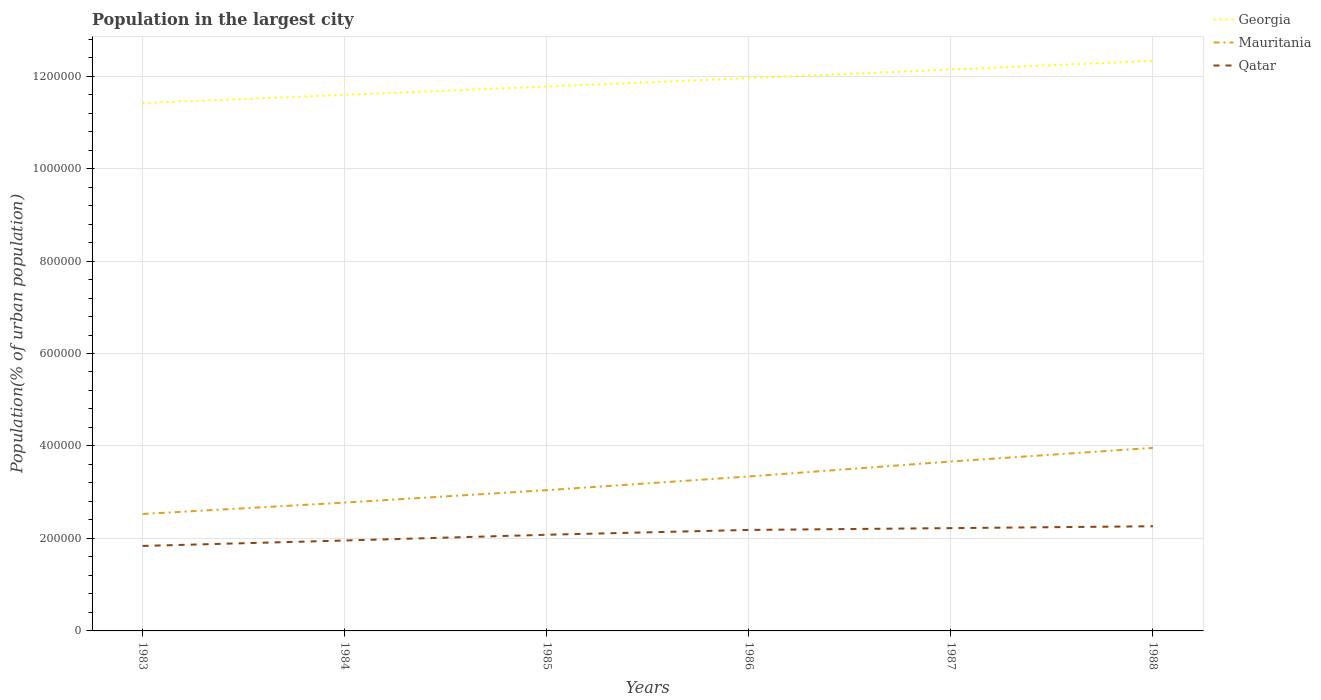Across all years, what is the maximum population in the largest city in Mauritania?
Provide a succinct answer. 2.53e+05. In which year was the population in the largest city in Qatar maximum?
Your answer should be very brief. 1983. What is the total population in the largest city in Georgia in the graph?
Make the answer very short. -1.85e+04. What is the difference between the highest and the second highest population in the largest city in Mauritania?
Ensure brevity in your answer.  1.43e+05. Are the values on the major ticks of Y-axis written in scientific E-notation?
Your answer should be very brief. No. Does the graph contain any zero values?
Provide a short and direct response. No. Does the graph contain grids?
Offer a very short reply. Yes. How are the legend labels stacked?
Make the answer very short. Vertical. What is the title of the graph?
Keep it short and to the point. Population in the largest city. What is the label or title of the Y-axis?
Provide a short and direct response. Population(% of urban population). What is the Population(% of urban population) in Georgia in 1983?
Provide a succinct answer. 1.14e+06. What is the Population(% of urban population) of Mauritania in 1983?
Give a very brief answer. 2.53e+05. What is the Population(% of urban population) of Qatar in 1983?
Your answer should be very brief. 1.84e+05. What is the Population(% of urban population) in Georgia in 1984?
Provide a succinct answer. 1.16e+06. What is the Population(% of urban population) of Mauritania in 1984?
Give a very brief answer. 2.78e+05. What is the Population(% of urban population) in Qatar in 1984?
Ensure brevity in your answer.  1.96e+05. What is the Population(% of urban population) in Georgia in 1985?
Provide a short and direct response. 1.18e+06. What is the Population(% of urban population) in Mauritania in 1985?
Your response must be concise. 3.04e+05. What is the Population(% of urban population) in Qatar in 1985?
Give a very brief answer. 2.08e+05. What is the Population(% of urban population) of Georgia in 1986?
Keep it short and to the point. 1.20e+06. What is the Population(% of urban population) of Mauritania in 1986?
Make the answer very short. 3.34e+05. What is the Population(% of urban population) of Qatar in 1986?
Ensure brevity in your answer.  2.18e+05. What is the Population(% of urban population) in Georgia in 1987?
Offer a very short reply. 1.21e+06. What is the Population(% of urban population) in Mauritania in 1987?
Your answer should be very brief. 3.66e+05. What is the Population(% of urban population) of Qatar in 1987?
Offer a terse response. 2.22e+05. What is the Population(% of urban population) in Georgia in 1988?
Offer a terse response. 1.23e+06. What is the Population(% of urban population) of Mauritania in 1988?
Provide a succinct answer. 3.96e+05. What is the Population(% of urban population) of Qatar in 1988?
Your answer should be very brief. 2.26e+05. Across all years, what is the maximum Population(% of urban population) of Georgia?
Provide a succinct answer. 1.23e+06. Across all years, what is the maximum Population(% of urban population) in Mauritania?
Make the answer very short. 3.96e+05. Across all years, what is the maximum Population(% of urban population) of Qatar?
Keep it short and to the point. 2.26e+05. Across all years, what is the minimum Population(% of urban population) in Georgia?
Offer a terse response. 1.14e+06. Across all years, what is the minimum Population(% of urban population) in Mauritania?
Your response must be concise. 2.53e+05. Across all years, what is the minimum Population(% of urban population) of Qatar?
Keep it short and to the point. 1.84e+05. What is the total Population(% of urban population) in Georgia in the graph?
Provide a short and direct response. 7.12e+06. What is the total Population(% of urban population) of Mauritania in the graph?
Offer a very short reply. 1.93e+06. What is the total Population(% of urban population) in Qatar in the graph?
Give a very brief answer. 1.25e+06. What is the difference between the Population(% of urban population) in Georgia in 1983 and that in 1984?
Your answer should be very brief. -1.77e+04. What is the difference between the Population(% of urban population) in Mauritania in 1983 and that in 1984?
Provide a short and direct response. -2.46e+04. What is the difference between the Population(% of urban population) in Qatar in 1983 and that in 1984?
Offer a very short reply. -1.17e+04. What is the difference between the Population(% of urban population) of Georgia in 1983 and that in 1985?
Your answer should be compact. -3.57e+04. What is the difference between the Population(% of urban population) in Mauritania in 1983 and that in 1985?
Your answer should be very brief. -5.15e+04. What is the difference between the Population(% of urban population) of Qatar in 1983 and that in 1985?
Provide a succinct answer. -2.42e+04. What is the difference between the Population(% of urban population) of Georgia in 1983 and that in 1986?
Provide a succinct answer. -5.39e+04. What is the difference between the Population(% of urban population) of Mauritania in 1983 and that in 1986?
Your response must be concise. -8.11e+04. What is the difference between the Population(% of urban population) of Qatar in 1983 and that in 1986?
Offer a very short reply. -3.46e+04. What is the difference between the Population(% of urban population) of Georgia in 1983 and that in 1987?
Make the answer very short. -7.25e+04. What is the difference between the Population(% of urban population) of Mauritania in 1983 and that in 1987?
Provide a succinct answer. -1.14e+05. What is the difference between the Population(% of urban population) in Qatar in 1983 and that in 1987?
Provide a short and direct response. -3.85e+04. What is the difference between the Population(% of urban population) in Georgia in 1983 and that in 1988?
Provide a succinct answer. -9.13e+04. What is the difference between the Population(% of urban population) in Mauritania in 1983 and that in 1988?
Your response must be concise. -1.43e+05. What is the difference between the Population(% of urban population) in Qatar in 1983 and that in 1988?
Your answer should be compact. -4.25e+04. What is the difference between the Population(% of urban population) of Georgia in 1984 and that in 1985?
Offer a terse response. -1.80e+04. What is the difference between the Population(% of urban population) of Mauritania in 1984 and that in 1985?
Ensure brevity in your answer.  -2.69e+04. What is the difference between the Population(% of urban population) of Qatar in 1984 and that in 1985?
Provide a succinct answer. -1.25e+04. What is the difference between the Population(% of urban population) in Georgia in 1984 and that in 1986?
Your response must be concise. -3.62e+04. What is the difference between the Population(% of urban population) in Mauritania in 1984 and that in 1986?
Offer a terse response. -5.65e+04. What is the difference between the Population(% of urban population) of Qatar in 1984 and that in 1986?
Make the answer very short. -2.29e+04. What is the difference between the Population(% of urban population) in Georgia in 1984 and that in 1987?
Provide a short and direct response. -5.47e+04. What is the difference between the Population(% of urban population) of Mauritania in 1984 and that in 1987?
Your answer should be very brief. -8.89e+04. What is the difference between the Population(% of urban population) in Qatar in 1984 and that in 1987?
Keep it short and to the point. -2.68e+04. What is the difference between the Population(% of urban population) in Georgia in 1984 and that in 1988?
Give a very brief answer. -7.36e+04. What is the difference between the Population(% of urban population) in Mauritania in 1984 and that in 1988?
Keep it short and to the point. -1.18e+05. What is the difference between the Population(% of urban population) in Qatar in 1984 and that in 1988?
Offer a terse response. -3.08e+04. What is the difference between the Population(% of urban population) in Georgia in 1985 and that in 1986?
Make the answer very short. -1.83e+04. What is the difference between the Population(% of urban population) in Mauritania in 1985 and that in 1986?
Offer a terse response. -2.96e+04. What is the difference between the Population(% of urban population) of Qatar in 1985 and that in 1986?
Your response must be concise. -1.04e+04. What is the difference between the Population(% of urban population) of Georgia in 1985 and that in 1987?
Your answer should be very brief. -3.68e+04. What is the difference between the Population(% of urban population) of Mauritania in 1985 and that in 1987?
Your answer should be very brief. -6.20e+04. What is the difference between the Population(% of urban population) of Qatar in 1985 and that in 1987?
Provide a short and direct response. -1.43e+04. What is the difference between the Population(% of urban population) of Georgia in 1985 and that in 1988?
Make the answer very short. -5.56e+04. What is the difference between the Population(% of urban population) of Mauritania in 1985 and that in 1988?
Offer a very short reply. -9.15e+04. What is the difference between the Population(% of urban population) in Qatar in 1985 and that in 1988?
Keep it short and to the point. -1.83e+04. What is the difference between the Population(% of urban population) in Georgia in 1986 and that in 1987?
Give a very brief answer. -1.85e+04. What is the difference between the Population(% of urban population) of Mauritania in 1986 and that in 1987?
Your answer should be very brief. -3.24e+04. What is the difference between the Population(% of urban population) of Qatar in 1986 and that in 1987?
Your answer should be compact. -3916. What is the difference between the Population(% of urban population) in Georgia in 1986 and that in 1988?
Your answer should be very brief. -3.74e+04. What is the difference between the Population(% of urban population) of Mauritania in 1986 and that in 1988?
Keep it short and to the point. -6.19e+04. What is the difference between the Population(% of urban population) in Qatar in 1986 and that in 1988?
Your answer should be very brief. -7908. What is the difference between the Population(% of urban population) in Georgia in 1987 and that in 1988?
Give a very brief answer. -1.89e+04. What is the difference between the Population(% of urban population) in Mauritania in 1987 and that in 1988?
Keep it short and to the point. -2.95e+04. What is the difference between the Population(% of urban population) of Qatar in 1987 and that in 1988?
Make the answer very short. -3992. What is the difference between the Population(% of urban population) of Georgia in 1983 and the Population(% of urban population) of Mauritania in 1984?
Your answer should be very brief. 8.64e+05. What is the difference between the Population(% of urban population) of Georgia in 1983 and the Population(% of urban population) of Qatar in 1984?
Provide a short and direct response. 9.46e+05. What is the difference between the Population(% of urban population) in Mauritania in 1983 and the Population(% of urban population) in Qatar in 1984?
Make the answer very short. 5.74e+04. What is the difference between the Population(% of urban population) in Georgia in 1983 and the Population(% of urban population) in Mauritania in 1985?
Provide a succinct answer. 8.37e+05. What is the difference between the Population(% of urban population) in Georgia in 1983 and the Population(% of urban population) in Qatar in 1985?
Give a very brief answer. 9.34e+05. What is the difference between the Population(% of urban population) in Mauritania in 1983 and the Population(% of urban population) in Qatar in 1985?
Provide a succinct answer. 4.49e+04. What is the difference between the Population(% of urban population) of Georgia in 1983 and the Population(% of urban population) of Mauritania in 1986?
Offer a terse response. 8.08e+05. What is the difference between the Population(% of urban population) of Georgia in 1983 and the Population(% of urban population) of Qatar in 1986?
Provide a short and direct response. 9.23e+05. What is the difference between the Population(% of urban population) of Mauritania in 1983 and the Population(% of urban population) of Qatar in 1986?
Provide a succinct answer. 3.45e+04. What is the difference between the Population(% of urban population) in Georgia in 1983 and the Population(% of urban population) in Mauritania in 1987?
Provide a succinct answer. 7.75e+05. What is the difference between the Population(% of urban population) in Georgia in 1983 and the Population(% of urban population) in Qatar in 1987?
Provide a succinct answer. 9.19e+05. What is the difference between the Population(% of urban population) in Mauritania in 1983 and the Population(% of urban population) in Qatar in 1987?
Offer a terse response. 3.06e+04. What is the difference between the Population(% of urban population) of Georgia in 1983 and the Population(% of urban population) of Mauritania in 1988?
Ensure brevity in your answer.  7.46e+05. What is the difference between the Population(% of urban population) in Georgia in 1983 and the Population(% of urban population) in Qatar in 1988?
Keep it short and to the point. 9.15e+05. What is the difference between the Population(% of urban population) in Mauritania in 1983 and the Population(% of urban population) in Qatar in 1988?
Provide a short and direct response. 2.66e+04. What is the difference between the Population(% of urban population) of Georgia in 1984 and the Population(% of urban population) of Mauritania in 1985?
Offer a very short reply. 8.55e+05. What is the difference between the Population(% of urban population) of Georgia in 1984 and the Population(% of urban population) of Qatar in 1985?
Give a very brief answer. 9.51e+05. What is the difference between the Population(% of urban population) in Mauritania in 1984 and the Population(% of urban population) in Qatar in 1985?
Ensure brevity in your answer.  6.95e+04. What is the difference between the Population(% of urban population) of Georgia in 1984 and the Population(% of urban population) of Mauritania in 1986?
Offer a terse response. 8.25e+05. What is the difference between the Population(% of urban population) in Georgia in 1984 and the Population(% of urban population) in Qatar in 1986?
Provide a short and direct response. 9.41e+05. What is the difference between the Population(% of urban population) in Mauritania in 1984 and the Population(% of urban population) in Qatar in 1986?
Your response must be concise. 5.91e+04. What is the difference between the Population(% of urban population) in Georgia in 1984 and the Population(% of urban population) in Mauritania in 1987?
Ensure brevity in your answer.  7.93e+05. What is the difference between the Population(% of urban population) in Georgia in 1984 and the Population(% of urban population) in Qatar in 1987?
Make the answer very short. 9.37e+05. What is the difference between the Population(% of urban population) in Mauritania in 1984 and the Population(% of urban population) in Qatar in 1987?
Provide a succinct answer. 5.52e+04. What is the difference between the Population(% of urban population) of Georgia in 1984 and the Population(% of urban population) of Mauritania in 1988?
Ensure brevity in your answer.  7.63e+05. What is the difference between the Population(% of urban population) of Georgia in 1984 and the Population(% of urban population) of Qatar in 1988?
Your answer should be compact. 9.33e+05. What is the difference between the Population(% of urban population) of Mauritania in 1984 and the Population(% of urban population) of Qatar in 1988?
Keep it short and to the point. 5.12e+04. What is the difference between the Population(% of urban population) in Georgia in 1985 and the Population(% of urban population) in Mauritania in 1986?
Make the answer very short. 8.43e+05. What is the difference between the Population(% of urban population) of Georgia in 1985 and the Population(% of urban population) of Qatar in 1986?
Your answer should be very brief. 9.59e+05. What is the difference between the Population(% of urban population) in Mauritania in 1985 and the Population(% of urban population) in Qatar in 1986?
Ensure brevity in your answer.  8.60e+04. What is the difference between the Population(% of urban population) of Georgia in 1985 and the Population(% of urban population) of Mauritania in 1987?
Offer a terse response. 8.11e+05. What is the difference between the Population(% of urban population) in Georgia in 1985 and the Population(% of urban population) in Qatar in 1987?
Provide a short and direct response. 9.55e+05. What is the difference between the Population(% of urban population) of Mauritania in 1985 and the Population(% of urban population) of Qatar in 1987?
Offer a very short reply. 8.21e+04. What is the difference between the Population(% of urban population) of Georgia in 1985 and the Population(% of urban population) of Mauritania in 1988?
Offer a terse response. 7.81e+05. What is the difference between the Population(% of urban population) in Georgia in 1985 and the Population(% of urban population) in Qatar in 1988?
Offer a terse response. 9.51e+05. What is the difference between the Population(% of urban population) of Mauritania in 1985 and the Population(% of urban population) of Qatar in 1988?
Make the answer very short. 7.81e+04. What is the difference between the Population(% of urban population) in Georgia in 1986 and the Population(% of urban population) in Mauritania in 1987?
Offer a terse response. 8.29e+05. What is the difference between the Population(% of urban population) in Georgia in 1986 and the Population(% of urban population) in Qatar in 1987?
Provide a succinct answer. 9.73e+05. What is the difference between the Population(% of urban population) in Mauritania in 1986 and the Population(% of urban population) in Qatar in 1987?
Keep it short and to the point. 1.12e+05. What is the difference between the Population(% of urban population) of Georgia in 1986 and the Population(% of urban population) of Mauritania in 1988?
Offer a terse response. 8.00e+05. What is the difference between the Population(% of urban population) of Georgia in 1986 and the Population(% of urban population) of Qatar in 1988?
Ensure brevity in your answer.  9.69e+05. What is the difference between the Population(% of urban population) of Mauritania in 1986 and the Population(% of urban population) of Qatar in 1988?
Your answer should be very brief. 1.08e+05. What is the difference between the Population(% of urban population) of Georgia in 1987 and the Population(% of urban population) of Mauritania in 1988?
Give a very brief answer. 8.18e+05. What is the difference between the Population(% of urban population) in Georgia in 1987 and the Population(% of urban population) in Qatar in 1988?
Provide a succinct answer. 9.88e+05. What is the difference between the Population(% of urban population) of Mauritania in 1987 and the Population(% of urban population) of Qatar in 1988?
Keep it short and to the point. 1.40e+05. What is the average Population(% of urban population) of Georgia per year?
Ensure brevity in your answer.  1.19e+06. What is the average Population(% of urban population) of Mauritania per year?
Make the answer very short. 3.22e+05. What is the average Population(% of urban population) of Qatar per year?
Your response must be concise. 2.09e+05. In the year 1983, what is the difference between the Population(% of urban population) of Georgia and Population(% of urban population) of Mauritania?
Provide a short and direct response. 8.89e+05. In the year 1983, what is the difference between the Population(% of urban population) of Georgia and Population(% of urban population) of Qatar?
Keep it short and to the point. 9.58e+05. In the year 1983, what is the difference between the Population(% of urban population) of Mauritania and Population(% of urban population) of Qatar?
Provide a short and direct response. 6.91e+04. In the year 1984, what is the difference between the Population(% of urban population) in Georgia and Population(% of urban population) in Mauritania?
Make the answer very short. 8.82e+05. In the year 1984, what is the difference between the Population(% of urban population) of Georgia and Population(% of urban population) of Qatar?
Offer a terse response. 9.64e+05. In the year 1984, what is the difference between the Population(% of urban population) in Mauritania and Population(% of urban population) in Qatar?
Make the answer very short. 8.20e+04. In the year 1985, what is the difference between the Population(% of urban population) in Georgia and Population(% of urban population) in Mauritania?
Your answer should be very brief. 8.73e+05. In the year 1985, what is the difference between the Population(% of urban population) in Georgia and Population(% of urban population) in Qatar?
Offer a terse response. 9.69e+05. In the year 1985, what is the difference between the Population(% of urban population) in Mauritania and Population(% of urban population) in Qatar?
Your answer should be very brief. 9.64e+04. In the year 1986, what is the difference between the Population(% of urban population) in Georgia and Population(% of urban population) in Mauritania?
Offer a terse response. 8.62e+05. In the year 1986, what is the difference between the Population(% of urban population) of Georgia and Population(% of urban population) of Qatar?
Your response must be concise. 9.77e+05. In the year 1986, what is the difference between the Population(% of urban population) of Mauritania and Population(% of urban population) of Qatar?
Offer a terse response. 1.16e+05. In the year 1987, what is the difference between the Population(% of urban population) in Georgia and Population(% of urban population) in Mauritania?
Give a very brief answer. 8.48e+05. In the year 1987, what is the difference between the Population(% of urban population) of Georgia and Population(% of urban population) of Qatar?
Provide a succinct answer. 9.92e+05. In the year 1987, what is the difference between the Population(% of urban population) in Mauritania and Population(% of urban population) in Qatar?
Make the answer very short. 1.44e+05. In the year 1988, what is the difference between the Population(% of urban population) of Georgia and Population(% of urban population) of Mauritania?
Give a very brief answer. 8.37e+05. In the year 1988, what is the difference between the Population(% of urban population) of Georgia and Population(% of urban population) of Qatar?
Make the answer very short. 1.01e+06. In the year 1988, what is the difference between the Population(% of urban population) in Mauritania and Population(% of urban population) in Qatar?
Give a very brief answer. 1.70e+05. What is the ratio of the Population(% of urban population) of Georgia in 1983 to that in 1984?
Give a very brief answer. 0.98. What is the ratio of the Population(% of urban population) of Mauritania in 1983 to that in 1984?
Offer a very short reply. 0.91. What is the ratio of the Population(% of urban population) in Qatar in 1983 to that in 1984?
Your response must be concise. 0.94. What is the ratio of the Population(% of urban population) in Georgia in 1983 to that in 1985?
Make the answer very short. 0.97. What is the ratio of the Population(% of urban population) of Mauritania in 1983 to that in 1985?
Give a very brief answer. 0.83. What is the ratio of the Population(% of urban population) of Qatar in 1983 to that in 1985?
Your answer should be very brief. 0.88. What is the ratio of the Population(% of urban population) in Georgia in 1983 to that in 1986?
Ensure brevity in your answer.  0.95. What is the ratio of the Population(% of urban population) of Mauritania in 1983 to that in 1986?
Ensure brevity in your answer.  0.76. What is the ratio of the Population(% of urban population) in Qatar in 1983 to that in 1986?
Make the answer very short. 0.84. What is the ratio of the Population(% of urban population) of Georgia in 1983 to that in 1987?
Your answer should be compact. 0.94. What is the ratio of the Population(% of urban population) of Mauritania in 1983 to that in 1987?
Your answer should be compact. 0.69. What is the ratio of the Population(% of urban population) in Qatar in 1983 to that in 1987?
Provide a succinct answer. 0.83. What is the ratio of the Population(% of urban population) in Georgia in 1983 to that in 1988?
Your response must be concise. 0.93. What is the ratio of the Population(% of urban population) in Mauritania in 1983 to that in 1988?
Keep it short and to the point. 0.64. What is the ratio of the Population(% of urban population) in Qatar in 1983 to that in 1988?
Keep it short and to the point. 0.81. What is the ratio of the Population(% of urban population) in Mauritania in 1984 to that in 1985?
Your answer should be compact. 0.91. What is the ratio of the Population(% of urban population) in Qatar in 1984 to that in 1985?
Ensure brevity in your answer.  0.94. What is the ratio of the Population(% of urban population) of Georgia in 1984 to that in 1986?
Offer a terse response. 0.97. What is the ratio of the Population(% of urban population) of Mauritania in 1984 to that in 1986?
Your answer should be very brief. 0.83. What is the ratio of the Population(% of urban population) in Qatar in 1984 to that in 1986?
Offer a terse response. 0.9. What is the ratio of the Population(% of urban population) of Georgia in 1984 to that in 1987?
Offer a terse response. 0.95. What is the ratio of the Population(% of urban population) in Mauritania in 1984 to that in 1987?
Offer a terse response. 0.76. What is the ratio of the Population(% of urban population) in Qatar in 1984 to that in 1987?
Your answer should be compact. 0.88. What is the ratio of the Population(% of urban population) of Georgia in 1984 to that in 1988?
Give a very brief answer. 0.94. What is the ratio of the Population(% of urban population) in Mauritania in 1984 to that in 1988?
Keep it short and to the point. 0.7. What is the ratio of the Population(% of urban population) of Qatar in 1984 to that in 1988?
Your response must be concise. 0.86. What is the ratio of the Population(% of urban population) in Georgia in 1985 to that in 1986?
Make the answer very short. 0.98. What is the ratio of the Population(% of urban population) in Mauritania in 1985 to that in 1986?
Provide a short and direct response. 0.91. What is the ratio of the Population(% of urban population) in Qatar in 1985 to that in 1986?
Provide a succinct answer. 0.95. What is the ratio of the Population(% of urban population) in Georgia in 1985 to that in 1987?
Give a very brief answer. 0.97. What is the ratio of the Population(% of urban population) in Mauritania in 1985 to that in 1987?
Your answer should be very brief. 0.83. What is the ratio of the Population(% of urban population) in Qatar in 1985 to that in 1987?
Your answer should be compact. 0.94. What is the ratio of the Population(% of urban population) in Georgia in 1985 to that in 1988?
Ensure brevity in your answer.  0.95. What is the ratio of the Population(% of urban population) in Mauritania in 1985 to that in 1988?
Offer a terse response. 0.77. What is the ratio of the Population(% of urban population) of Qatar in 1985 to that in 1988?
Offer a very short reply. 0.92. What is the ratio of the Population(% of urban population) of Georgia in 1986 to that in 1987?
Offer a terse response. 0.98. What is the ratio of the Population(% of urban population) of Mauritania in 1986 to that in 1987?
Your answer should be very brief. 0.91. What is the ratio of the Population(% of urban population) of Qatar in 1986 to that in 1987?
Your answer should be very brief. 0.98. What is the ratio of the Population(% of urban population) of Georgia in 1986 to that in 1988?
Keep it short and to the point. 0.97. What is the ratio of the Population(% of urban population) of Mauritania in 1986 to that in 1988?
Provide a succinct answer. 0.84. What is the ratio of the Population(% of urban population) in Qatar in 1986 to that in 1988?
Ensure brevity in your answer.  0.97. What is the ratio of the Population(% of urban population) of Georgia in 1987 to that in 1988?
Keep it short and to the point. 0.98. What is the ratio of the Population(% of urban population) of Mauritania in 1987 to that in 1988?
Your response must be concise. 0.93. What is the ratio of the Population(% of urban population) in Qatar in 1987 to that in 1988?
Offer a terse response. 0.98. What is the difference between the highest and the second highest Population(% of urban population) in Georgia?
Ensure brevity in your answer.  1.89e+04. What is the difference between the highest and the second highest Population(% of urban population) of Mauritania?
Give a very brief answer. 2.95e+04. What is the difference between the highest and the second highest Population(% of urban population) in Qatar?
Keep it short and to the point. 3992. What is the difference between the highest and the lowest Population(% of urban population) in Georgia?
Give a very brief answer. 9.13e+04. What is the difference between the highest and the lowest Population(% of urban population) of Mauritania?
Keep it short and to the point. 1.43e+05. What is the difference between the highest and the lowest Population(% of urban population) in Qatar?
Keep it short and to the point. 4.25e+04. 